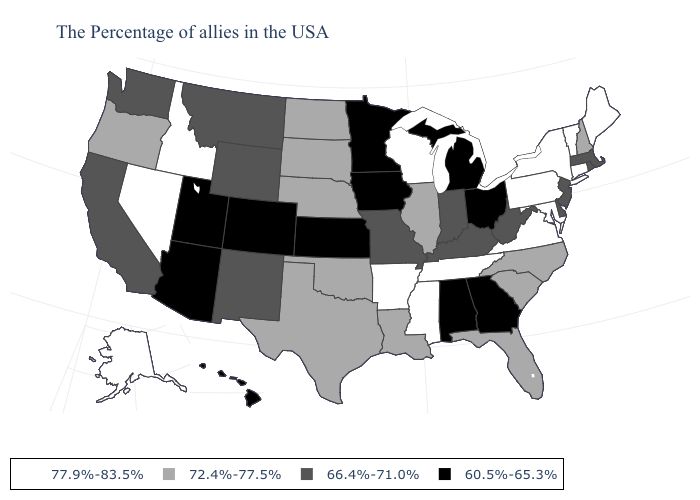Which states hav the highest value in the West?
Be succinct. Idaho, Nevada, Alaska. What is the value of Vermont?
Quick response, please. 77.9%-83.5%. Name the states that have a value in the range 60.5%-65.3%?
Short answer required. Ohio, Georgia, Michigan, Alabama, Minnesota, Iowa, Kansas, Colorado, Utah, Arizona, Hawaii. Name the states that have a value in the range 77.9%-83.5%?
Short answer required. Maine, Vermont, Connecticut, New York, Maryland, Pennsylvania, Virginia, Tennessee, Wisconsin, Mississippi, Arkansas, Idaho, Nevada, Alaska. Does Texas have a higher value than Montana?
Keep it brief. Yes. Does California have the same value as West Virginia?
Write a very short answer. Yes. Which states have the lowest value in the South?
Write a very short answer. Georgia, Alabama. Which states have the highest value in the USA?
Quick response, please. Maine, Vermont, Connecticut, New York, Maryland, Pennsylvania, Virginia, Tennessee, Wisconsin, Mississippi, Arkansas, Idaho, Nevada, Alaska. Is the legend a continuous bar?
Concise answer only. No. Among the states that border Connecticut , which have the lowest value?
Keep it brief. Massachusetts, Rhode Island. Name the states that have a value in the range 66.4%-71.0%?
Keep it brief. Massachusetts, Rhode Island, New Jersey, Delaware, West Virginia, Kentucky, Indiana, Missouri, Wyoming, New Mexico, Montana, California, Washington. What is the value of Tennessee?
Be succinct. 77.9%-83.5%. Does the first symbol in the legend represent the smallest category?
Be succinct. No. Does Louisiana have a higher value than Alabama?
Short answer required. Yes. What is the lowest value in states that border Indiana?
Be succinct. 60.5%-65.3%. 